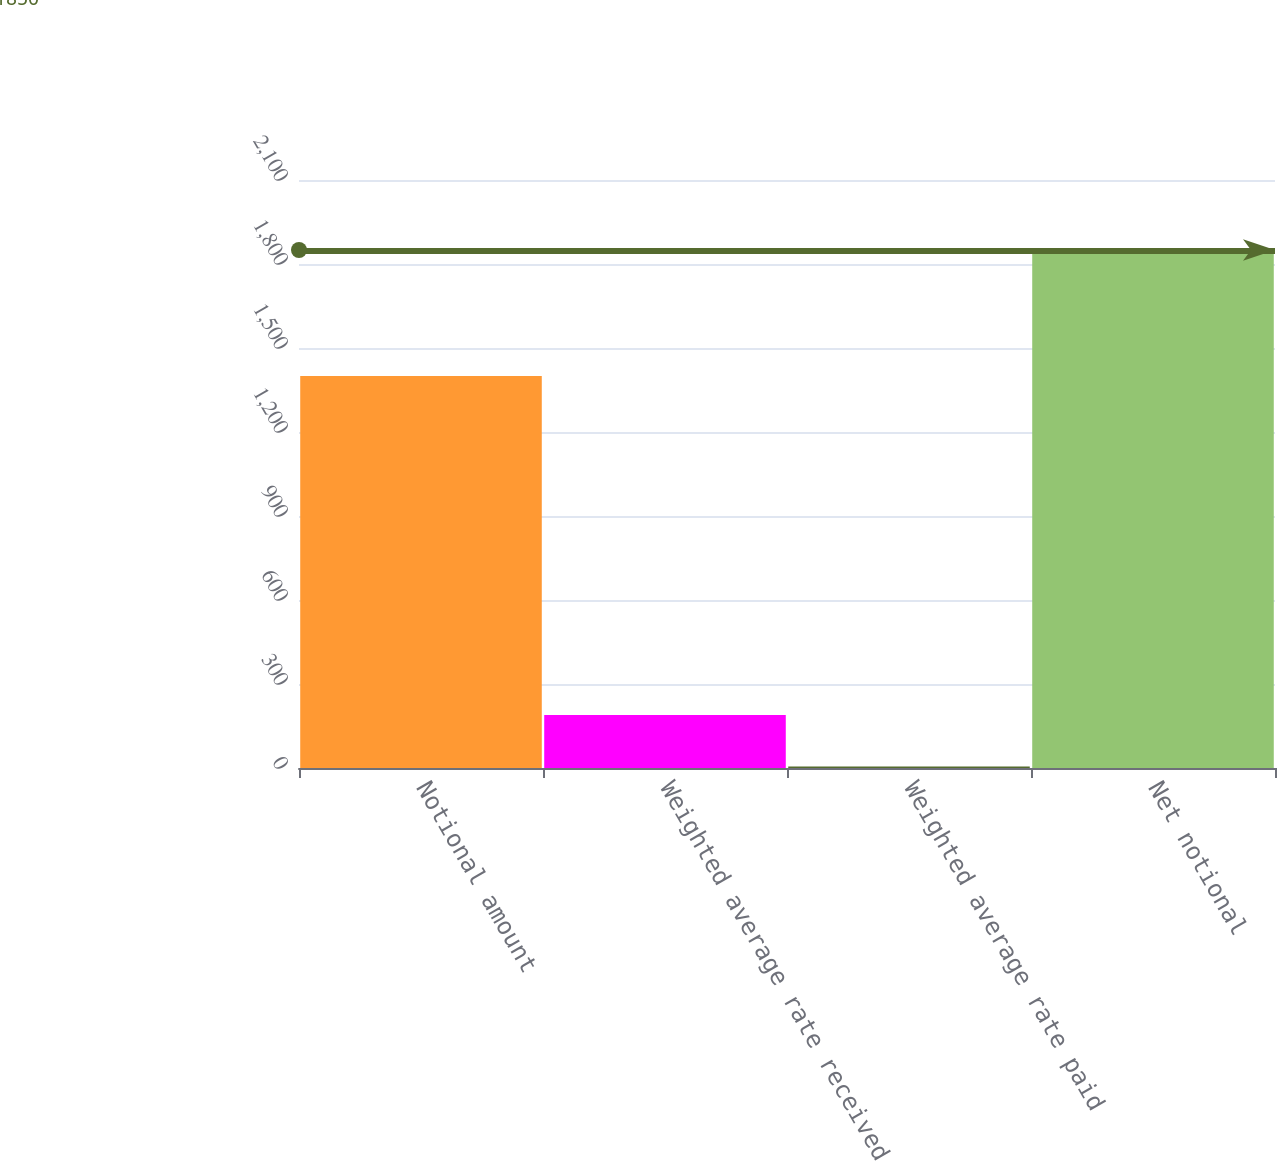Convert chart to OTSL. <chart><loc_0><loc_0><loc_500><loc_500><bar_chart><fcel>Notional amount<fcel>Weighted average rate received<fcel>Weighted average rate paid<fcel>Net notional<nl><fcel>1400<fcel>189.66<fcel>5.18<fcel>1850<nl></chart> 